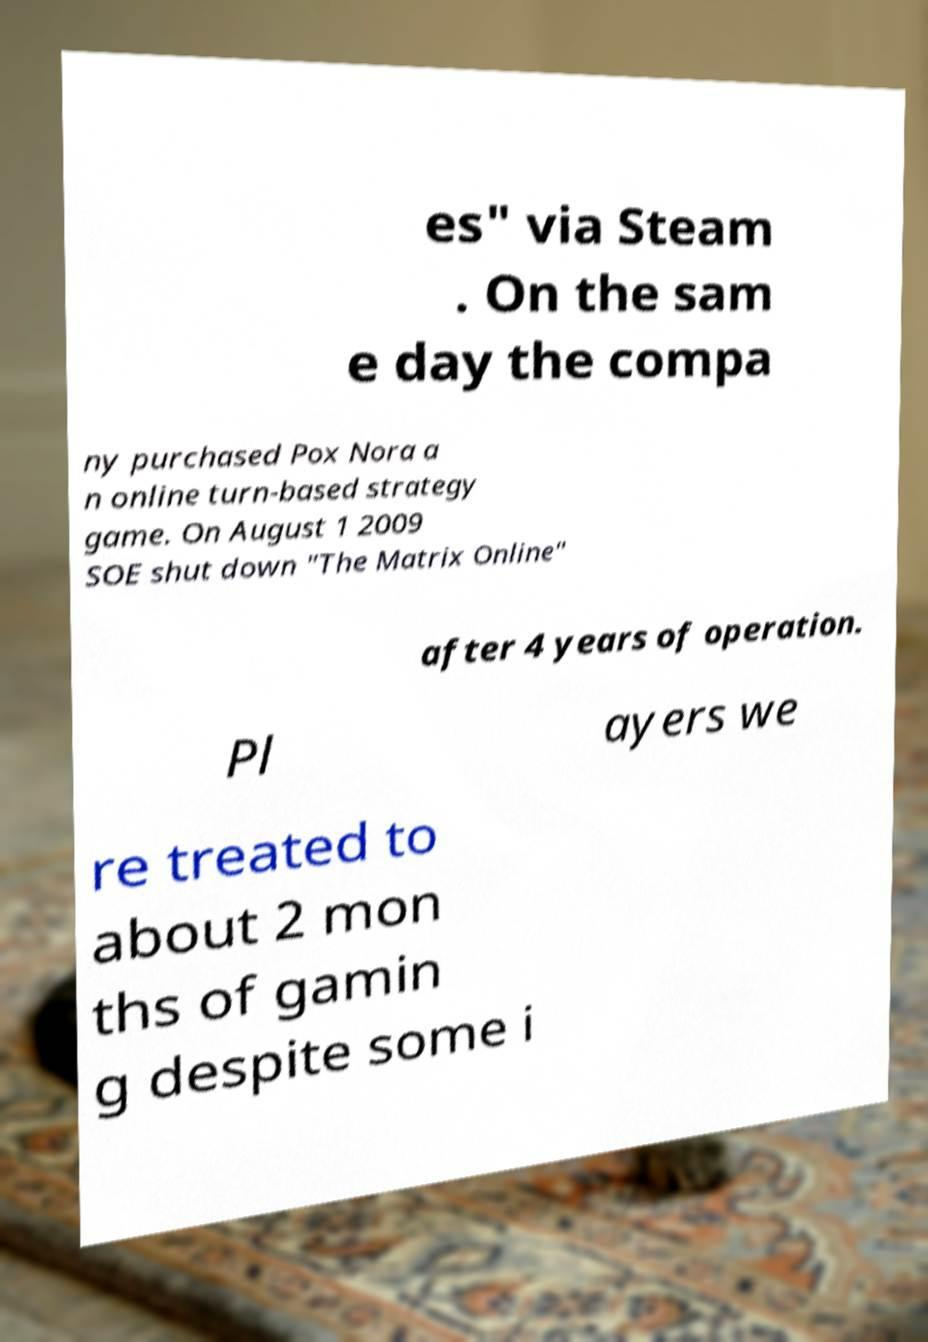Please identify and transcribe the text found in this image. es" via Steam . On the sam e day the compa ny purchased Pox Nora a n online turn-based strategy game. On August 1 2009 SOE shut down "The Matrix Online" after 4 years of operation. Pl ayers we re treated to about 2 mon ths of gamin g despite some i 